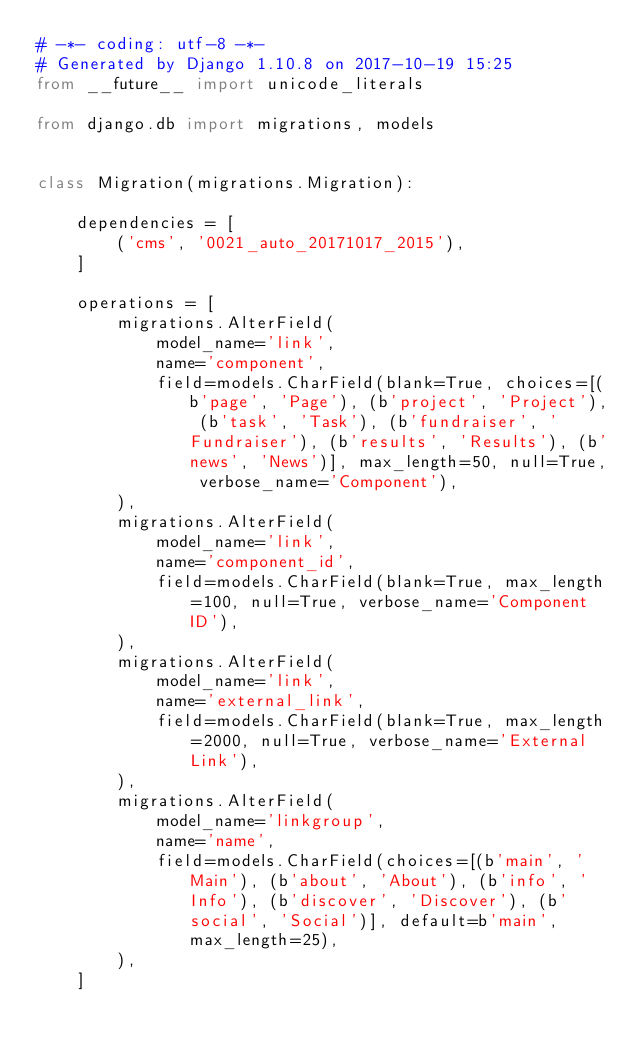<code> <loc_0><loc_0><loc_500><loc_500><_Python_># -*- coding: utf-8 -*-
# Generated by Django 1.10.8 on 2017-10-19 15:25
from __future__ import unicode_literals

from django.db import migrations, models


class Migration(migrations.Migration):

    dependencies = [
        ('cms', '0021_auto_20171017_2015'),
    ]

    operations = [
        migrations.AlterField(
            model_name='link',
            name='component',
            field=models.CharField(blank=True, choices=[(b'page', 'Page'), (b'project', 'Project'), (b'task', 'Task'), (b'fundraiser', 'Fundraiser'), (b'results', 'Results'), (b'news', 'News')], max_length=50, null=True, verbose_name='Component'),
        ),
        migrations.AlterField(
            model_name='link',
            name='component_id',
            field=models.CharField(blank=True, max_length=100, null=True, verbose_name='Component ID'),
        ),
        migrations.AlterField(
            model_name='link',
            name='external_link',
            field=models.CharField(blank=True, max_length=2000, null=True, verbose_name='External Link'),
        ),
        migrations.AlterField(
            model_name='linkgroup',
            name='name',
            field=models.CharField(choices=[(b'main', 'Main'), (b'about', 'About'), (b'info', 'Info'), (b'discover', 'Discover'), (b'social', 'Social')], default=b'main', max_length=25),
        ),
    ]
</code> 